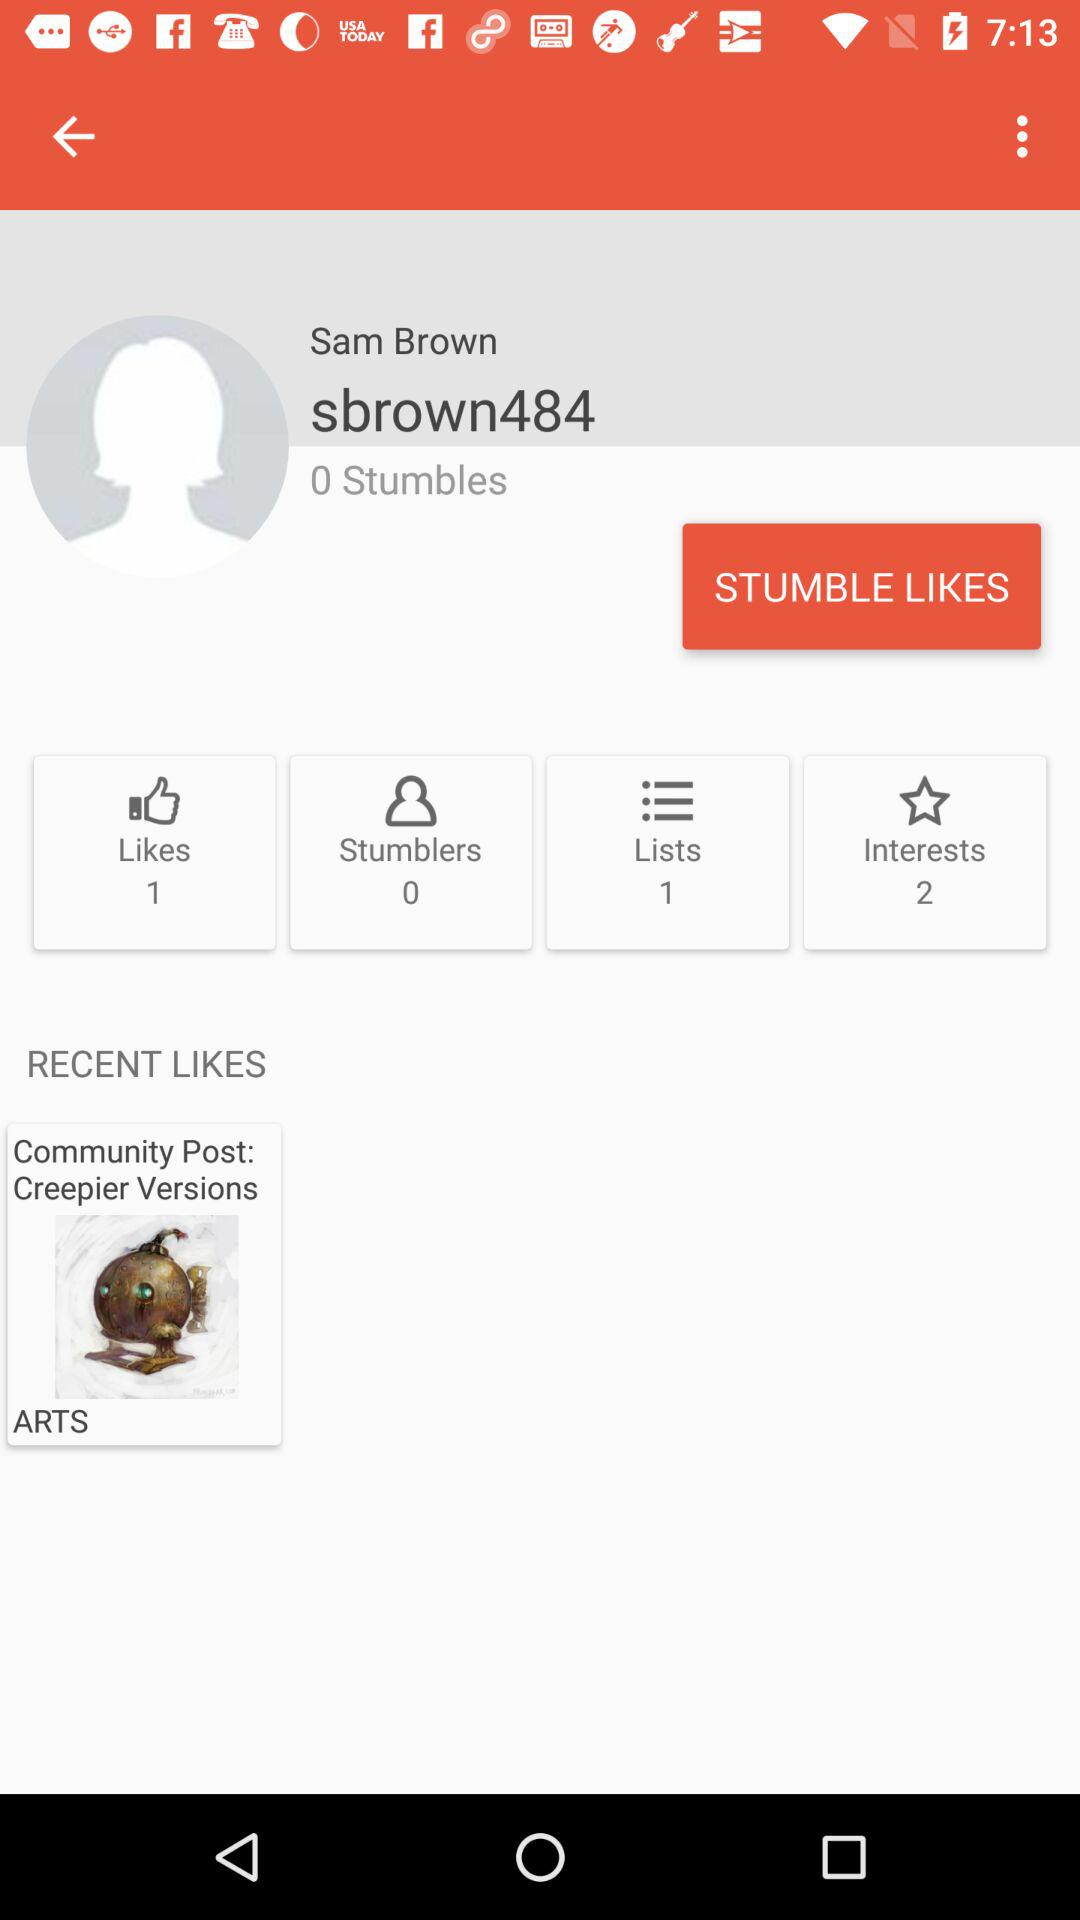How many lists are there? There is one list. 